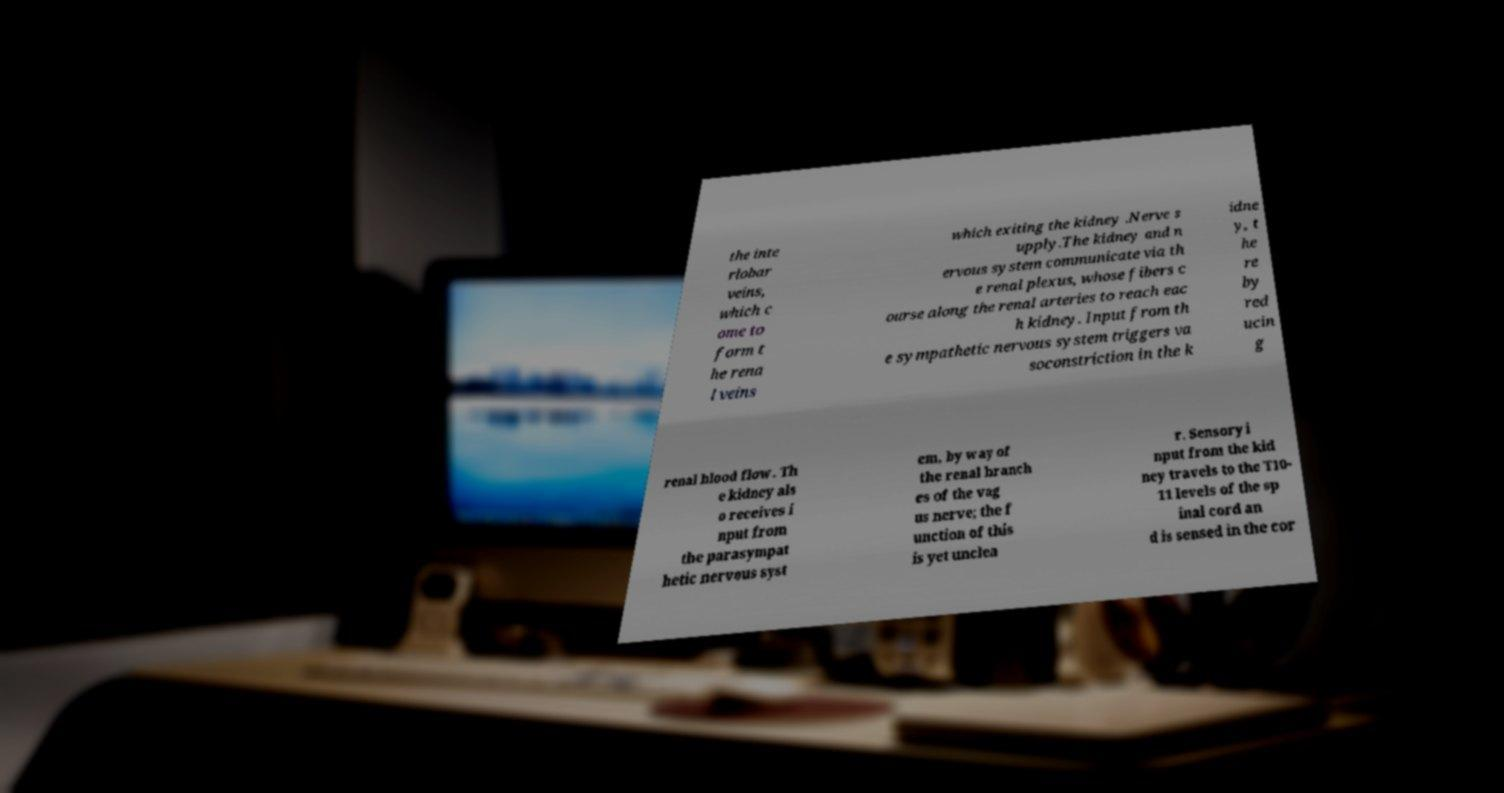What messages or text are displayed in this image? I need them in a readable, typed format. the inte rlobar veins, which c ome to form t he rena l veins which exiting the kidney .Nerve s upply.The kidney and n ervous system communicate via th e renal plexus, whose fibers c ourse along the renal arteries to reach eac h kidney. Input from th e sympathetic nervous system triggers va soconstriction in the k idne y, t he re by red ucin g renal blood flow. Th e kidney als o receives i nput from the parasympat hetic nervous syst em, by way of the renal branch es of the vag us nerve; the f unction of this is yet unclea r. Sensory i nput from the kid ney travels to the T10- 11 levels of the sp inal cord an d is sensed in the cor 